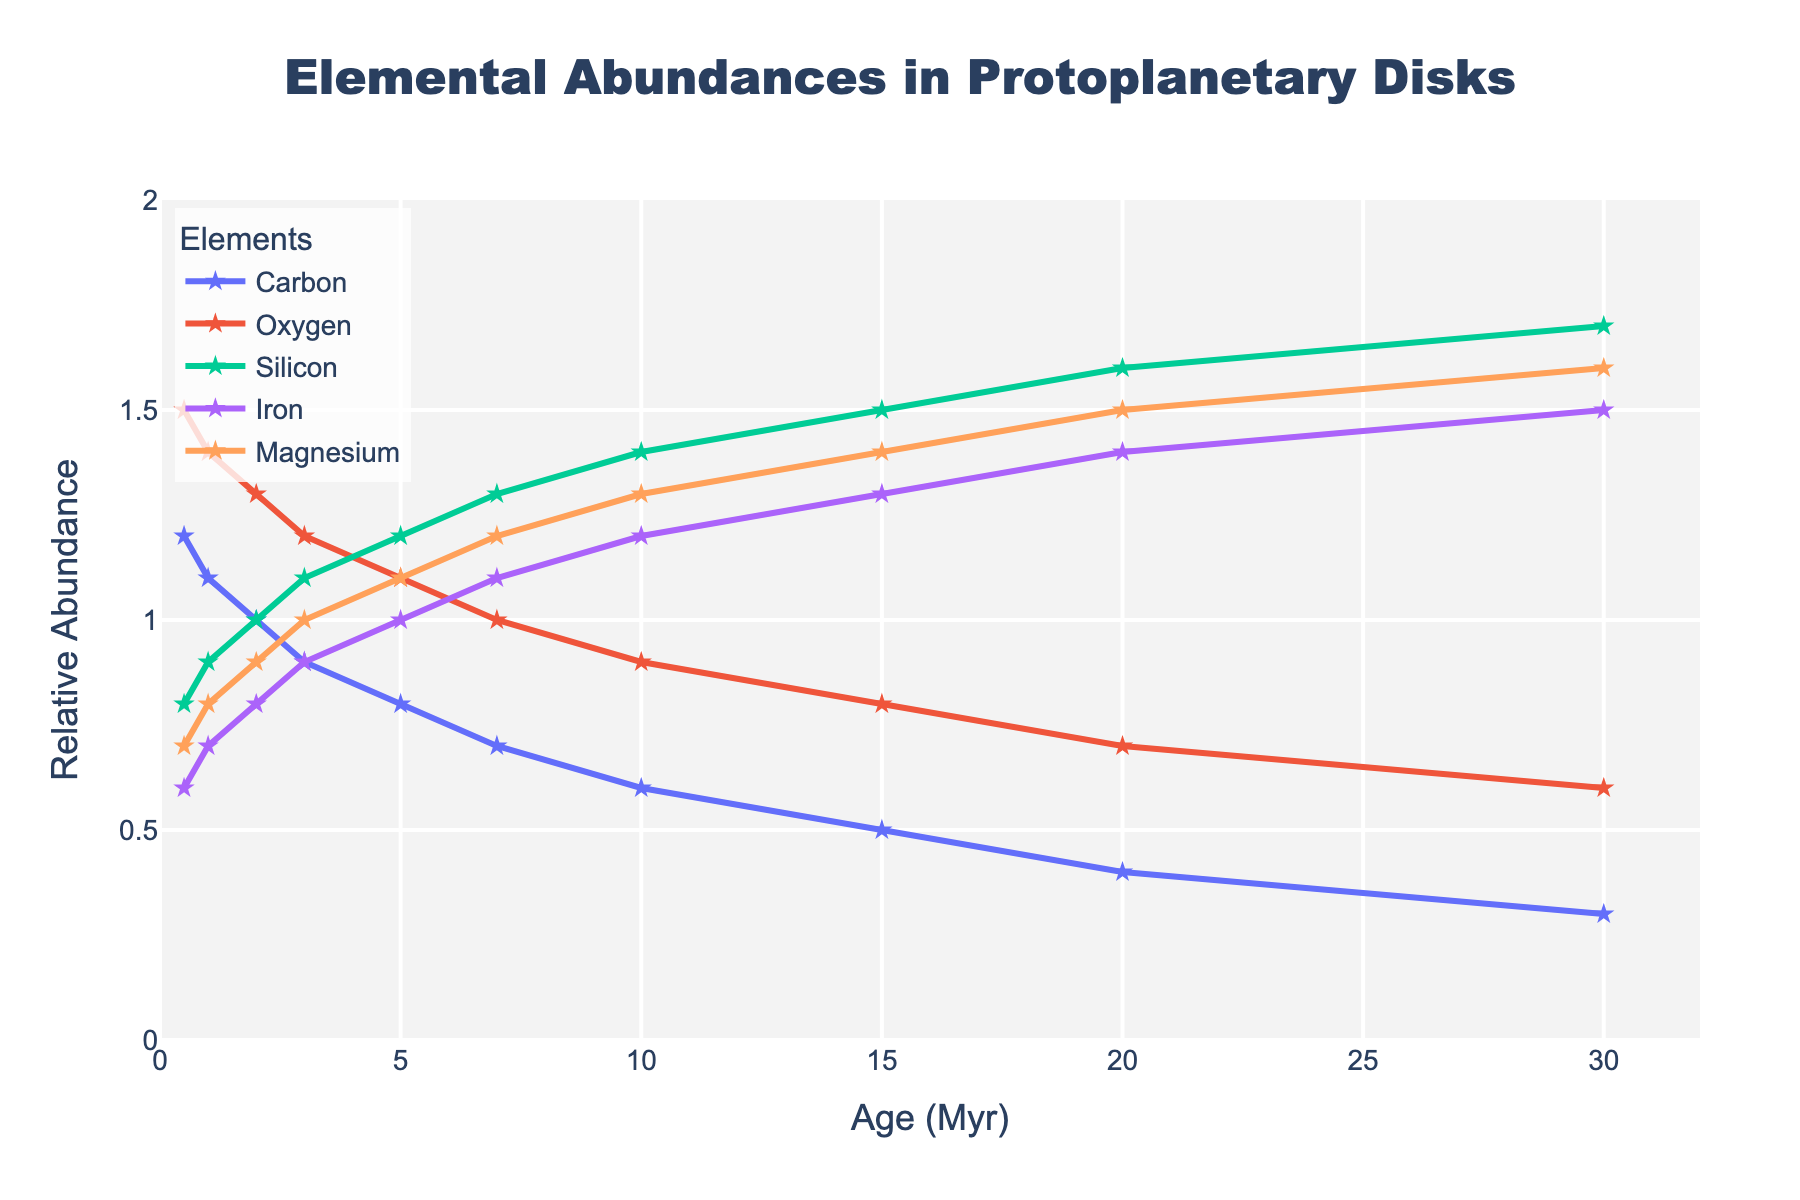What trend do you observe in the abundance of Carbon as the age increases? The abundance of Carbon decreases steadily from 1.2 at 0.5 Myr to 0.3 at 30 Myr. The line representing Carbon trends downward.
Answer: The abundance of Carbon decreases Which element shows the greatest increase in abundance over the age range? By examining the lines, Silicon shows the greatest increase in abundance, from 0.8 at 0.5 Myr to 1.7 at 30 Myr, making it the element with the greatest change.
Answer: Silicon At what age are the abundances of Iron and Magnesium equal? By looking at the graph, the abundances of Iron and Magnesium are equal at 15 Myr, where both elements have an abundance of 1.3.
Answer: 15 Myr How does the abundance of Oxygen compare between 10 Myr and 20 Myr? At 10 Myr, the abundance of Oxygen is 0.9, and at 20 Myr, it is 0.7. Therefore, Oxygen's abundance decreases by 0.2 over this period.
Answer: Decreases by 0.2 What is the average abundance of Iron over the ages represented? The abundance of Iron is an average of values (0.6 + 0.7 + 0.8 + 0.9 + 1.0 + 1.1 + 1.2 + 1.3 + 1.4 + 1.5) which sum up to 10.5. Dividing the sum by the number of age points (10) gives an average abundance of 1.05.
Answer: 1.05 Which element has the smallest change in abundance over the entire age range? By examining the graph, Oxygen shows a relatively small decline from 1.5 to 0.6 over the 30 Myr period, indicating the smallest change.
Answer: Oxygen When is the abundance of Magnesium exactly 1.0? By examining the graph, the abundance of Magnesium is 1.0 at 3 Myr.
Answer: 3 Myr How does the abundance of Silicon change from 5 Myr to 10 Myr? The abundance of Silicon increases from 1.2 at 5 Myr to 1.4 at 10 Myr, an increase of 0.2.
Answer: Increases by 0.2 